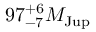<formula> <loc_0><loc_0><loc_500><loc_500>9 7 _ { - 7 } ^ { + 6 } M _ { J u p }</formula> 